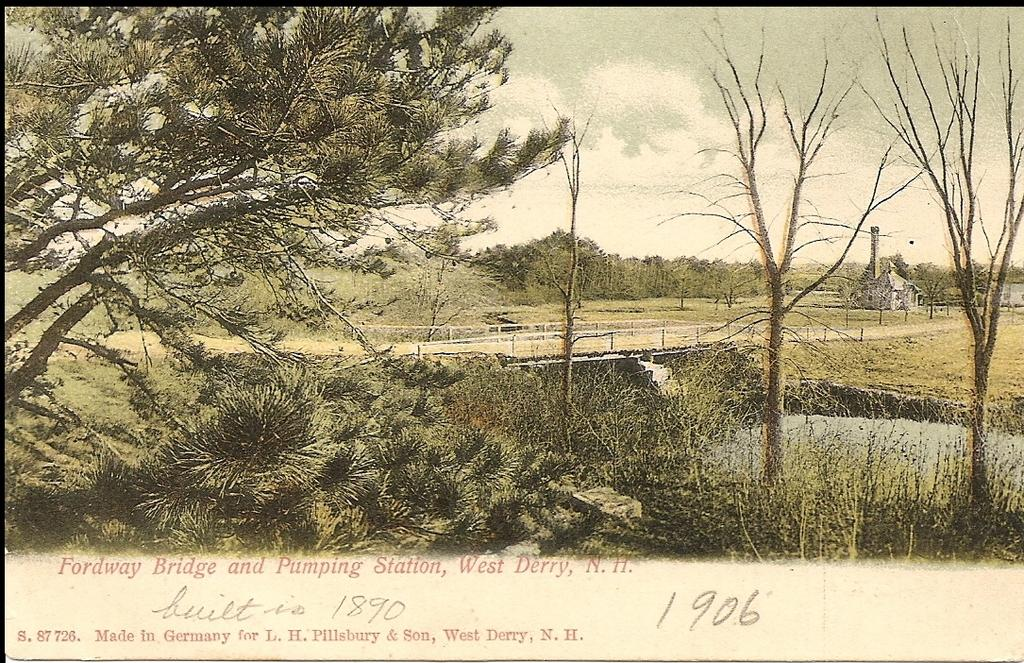What is the primary element visible in the image? There is water in the image. What structure can be seen crossing over the water? There is a bridge in the image. What feature does the bridge have? The bridge has railing. What type of building is present in the image? There is a house in the image. What type of vegetation can be seen in the image? There are plants and trees in the image. How would you describe the sky in the image? The sky is cloudy in the image. Is there any text present in the image? Yes, there is text written at the bottom of the image. Can you see a gun being fired near the bridge in the image? No, there is no gun or any indication of a gun being fired in the image. 